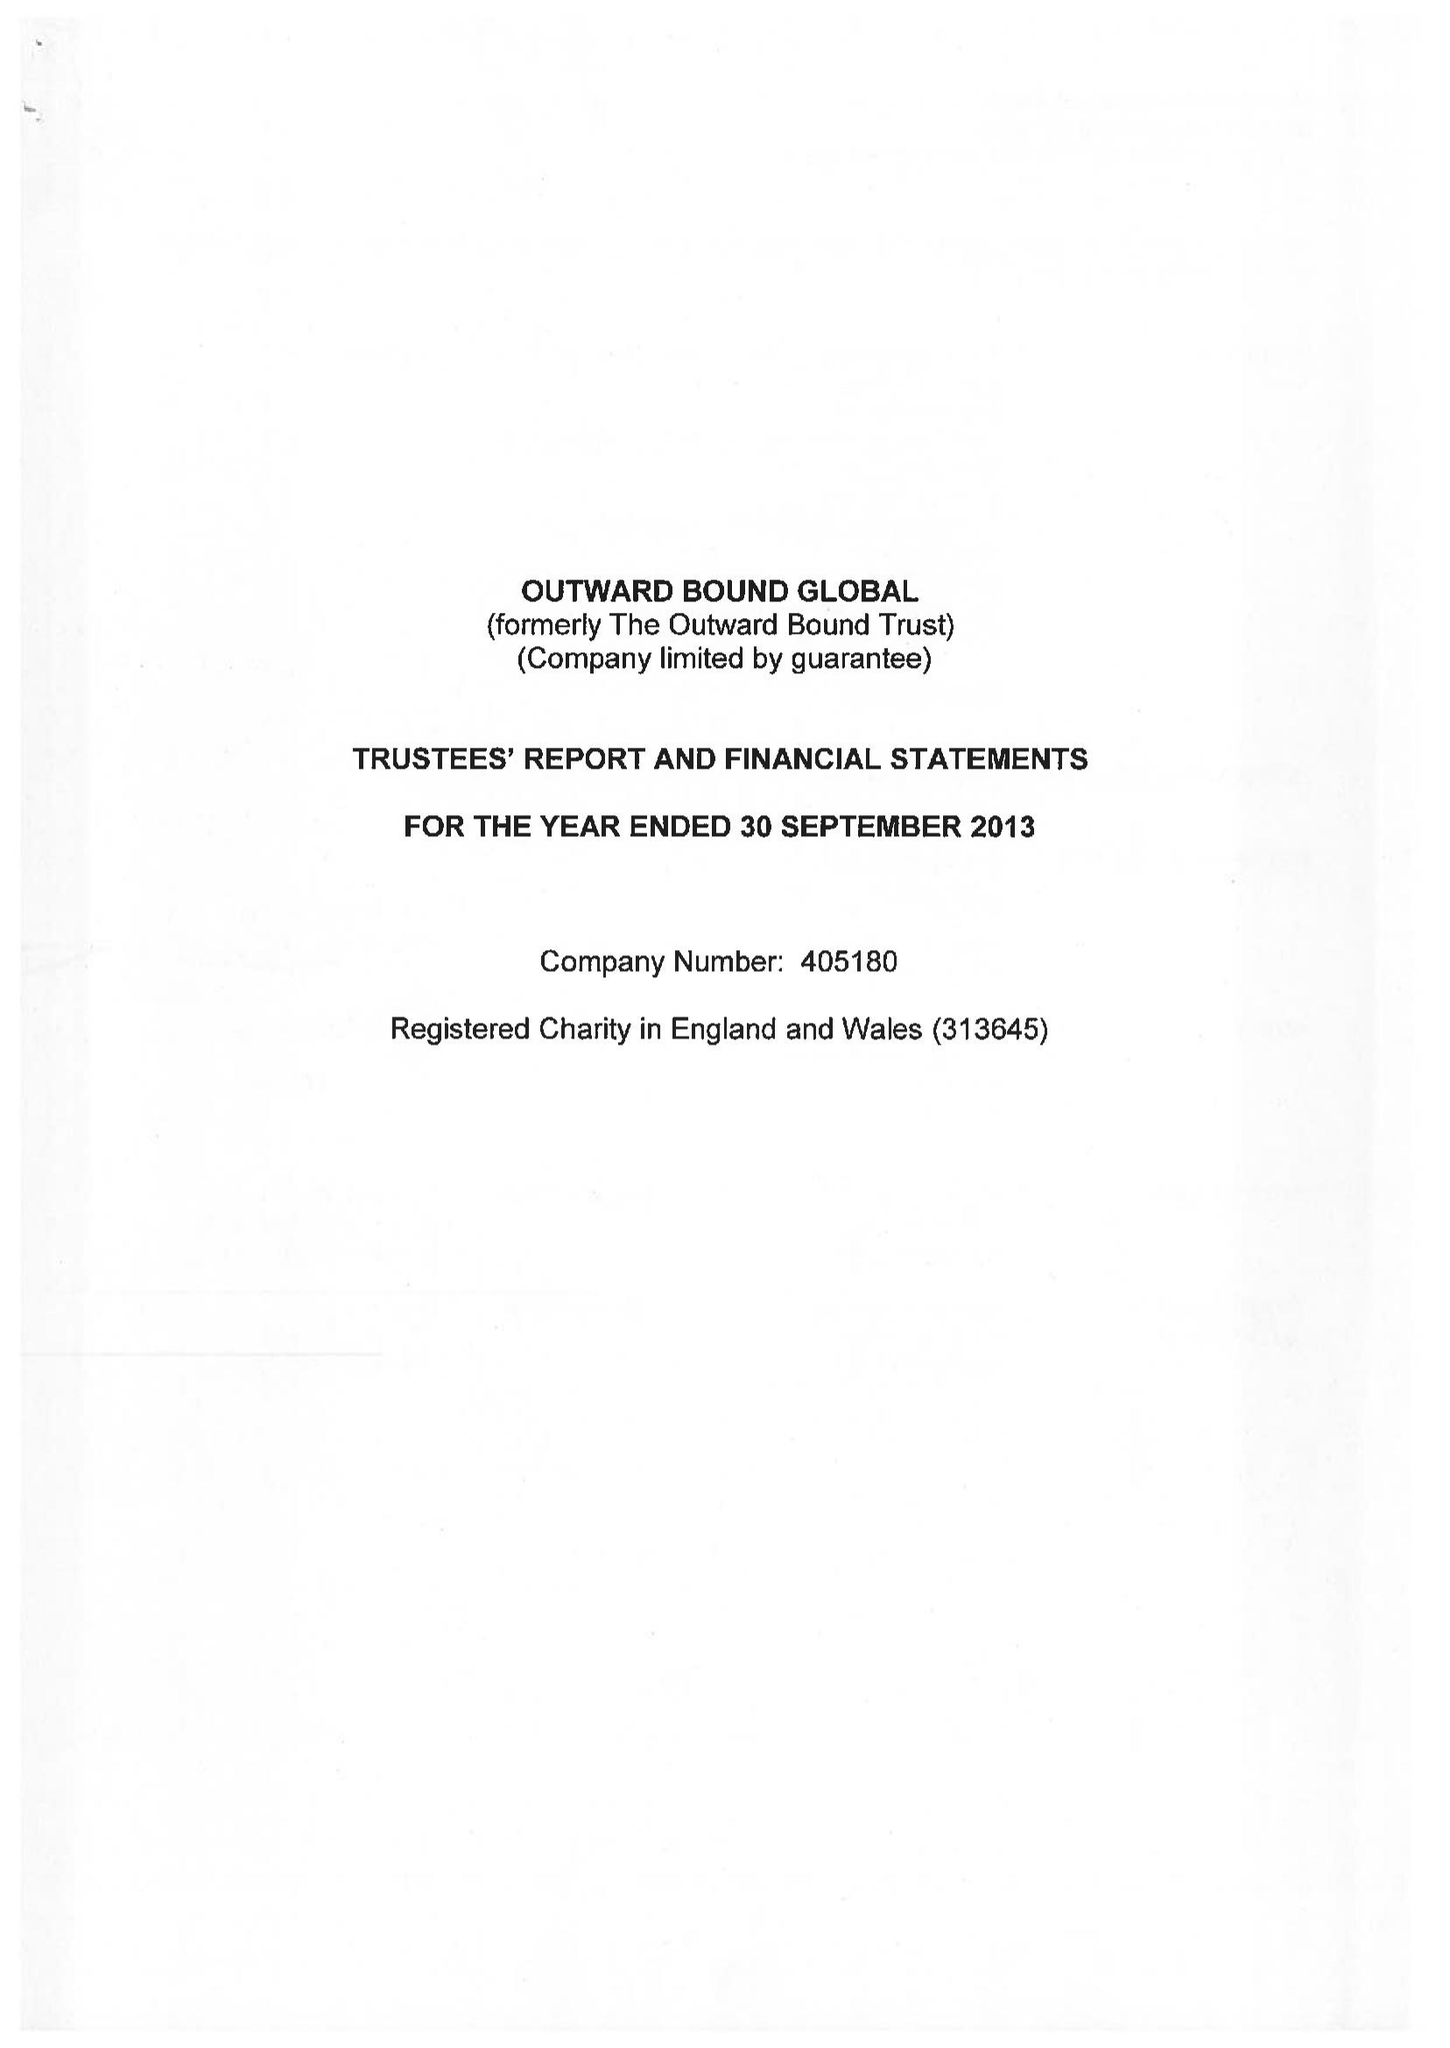What is the value for the income_annually_in_british_pounds?
Answer the question using a single word or phrase. 504868.00 